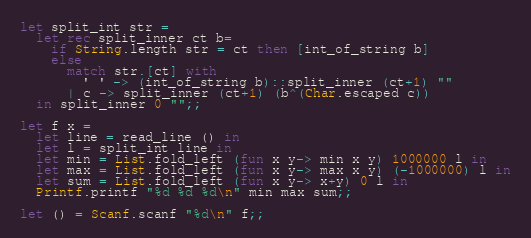Convert code to text. <code><loc_0><loc_0><loc_500><loc_500><_OCaml_>let split_int str =
  let rec split_inner ct b=
    if String.length str = ct then [int_of_string b]
    else
      match str.[ct] with
        ' ' -> (int_of_string b)::split_inner (ct+1) ""
      | c -> split_inner (ct+1) (b^(Char.escaped c))
  in split_inner 0 "";;

let f x =
  let line = read_line () in
  let l = split_int line in
  let min = List.fold_left (fun x y-> min x y) 1000000 l in
  let max = List.fold_left (fun x y-> max x y) (-1000000) l in
  let sum = List.fold_left (fun x y-> x+y) 0 l in
  Printf.printf "%d %d %d\n" min max sum;;

let () = Scanf.scanf "%d\n" f;;</code> 